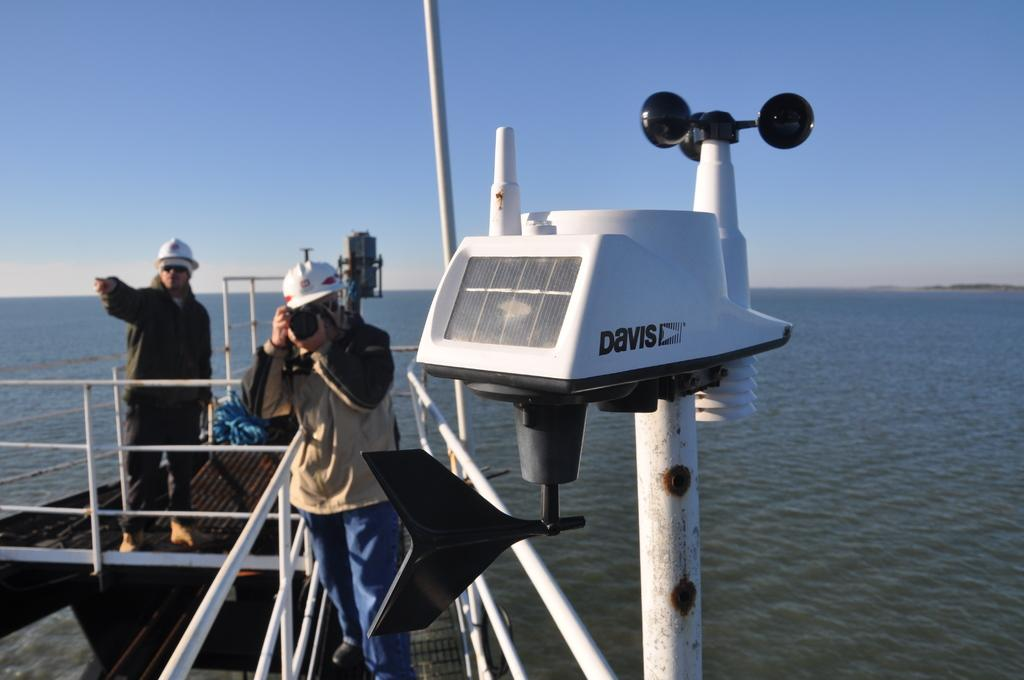<image>
Summarize the visual content of the image. a man is on a boat, taking a photo, and there is a Davis mechanism on the boat 